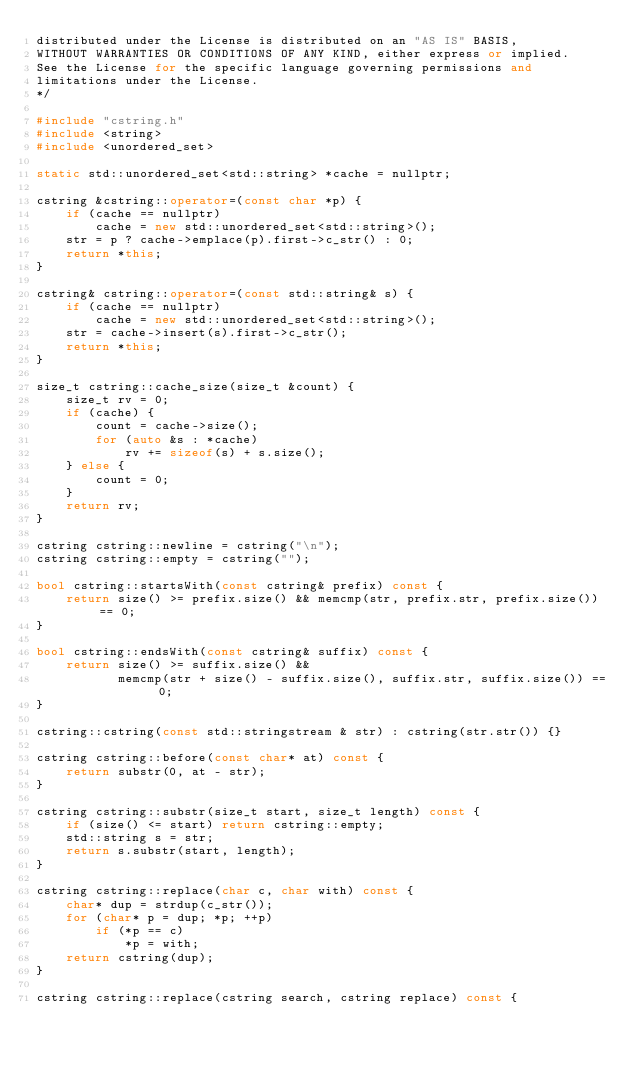<code> <loc_0><loc_0><loc_500><loc_500><_C++_>distributed under the License is distributed on an "AS IS" BASIS,
WITHOUT WARRANTIES OR CONDITIONS OF ANY KIND, either express or implied.
See the License for the specific language governing permissions and
limitations under the License.
*/

#include "cstring.h"
#include <string>
#include <unordered_set>

static std::unordered_set<std::string> *cache = nullptr;

cstring &cstring::operator=(const char *p) {
    if (cache == nullptr)
        cache = new std::unordered_set<std::string>();
    str = p ? cache->emplace(p).first->c_str() : 0;
    return *this;
}

cstring& cstring::operator=(const std::string& s) {
    if (cache == nullptr)
        cache = new std::unordered_set<std::string>();
    str = cache->insert(s).first->c_str();
    return *this;
}

size_t cstring::cache_size(size_t &count) {
    size_t rv = 0;
    if (cache) {
        count = cache->size();
        for (auto &s : *cache)
            rv += sizeof(s) + s.size();
    } else {
        count = 0;
    }
    return rv;
}

cstring cstring::newline = cstring("\n");
cstring cstring::empty = cstring("");

bool cstring::startsWith(const cstring& prefix) const {
    return size() >= prefix.size() && memcmp(str, prefix.str, prefix.size()) == 0;
}

bool cstring::endsWith(const cstring& suffix) const {
    return size() >= suffix.size() &&
           memcmp(str + size() - suffix.size(), suffix.str, suffix.size()) == 0;
}

cstring::cstring(const std::stringstream & str) : cstring(str.str()) {}

cstring cstring::before(const char* at) const {
    return substr(0, at - str);
}

cstring cstring::substr(size_t start, size_t length) const {
    if (size() <= start) return cstring::empty;
    std::string s = str;
    return s.substr(start, length);
}

cstring cstring::replace(char c, char with) const {
    char* dup = strdup(c_str());
    for (char* p = dup; *p; ++p)
        if (*p == c)
            *p = with;
    return cstring(dup);
}

cstring cstring::replace(cstring search, cstring replace) const {</code> 